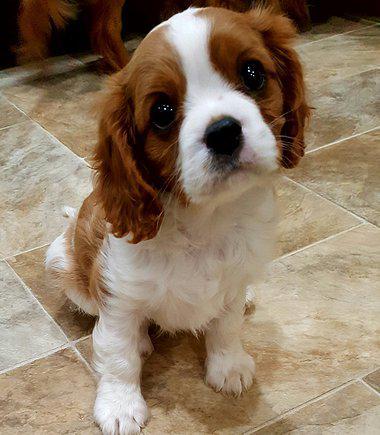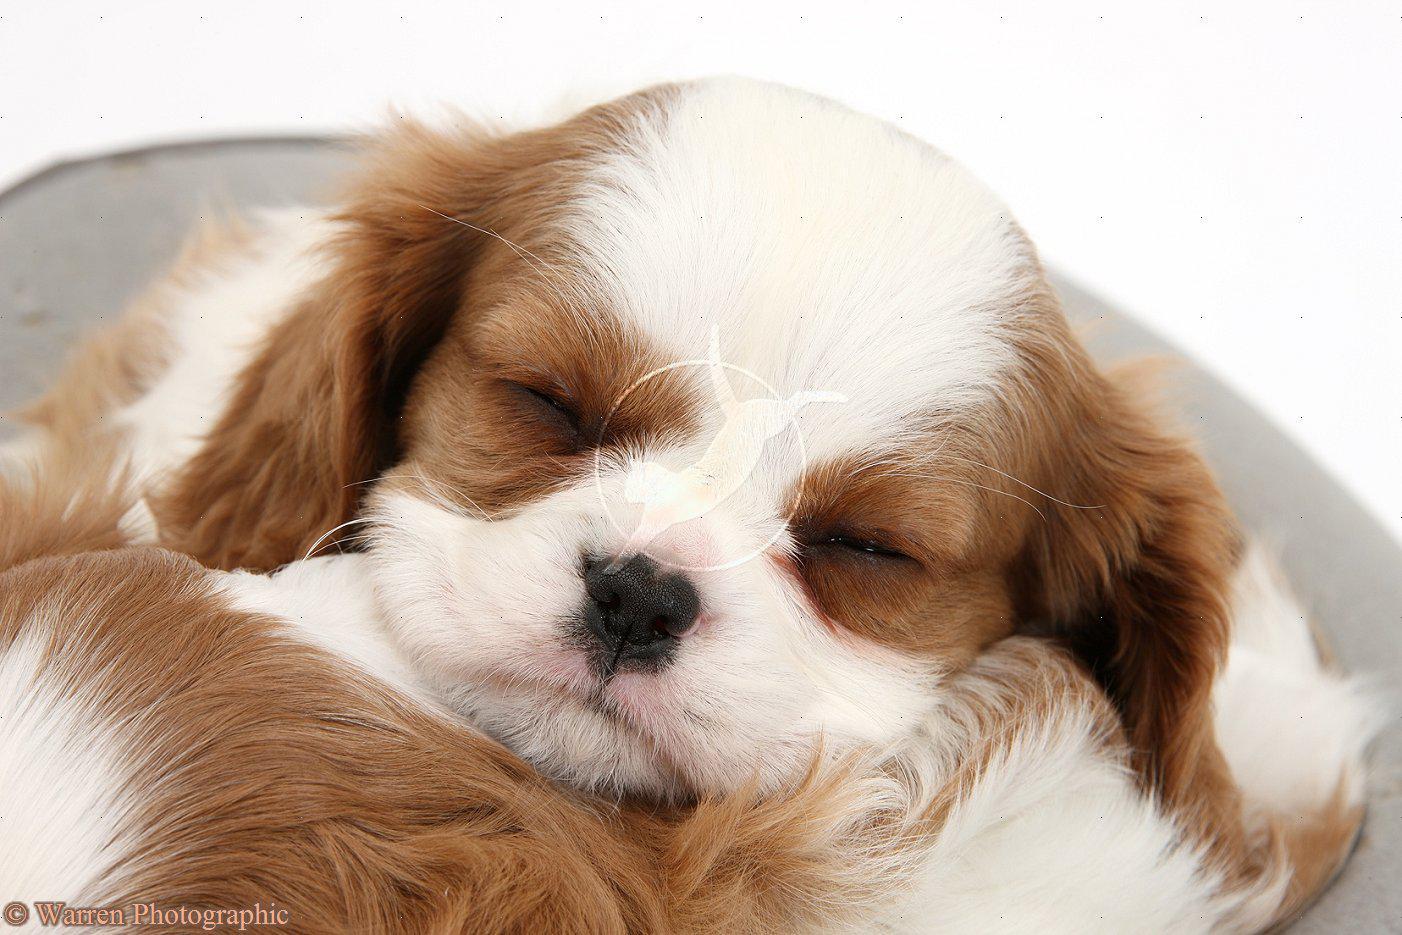The first image is the image on the left, the second image is the image on the right. Given the left and right images, does the statement "An image shows a brown and white puppy on a shiny wood floor." hold true? Answer yes or no. No. 